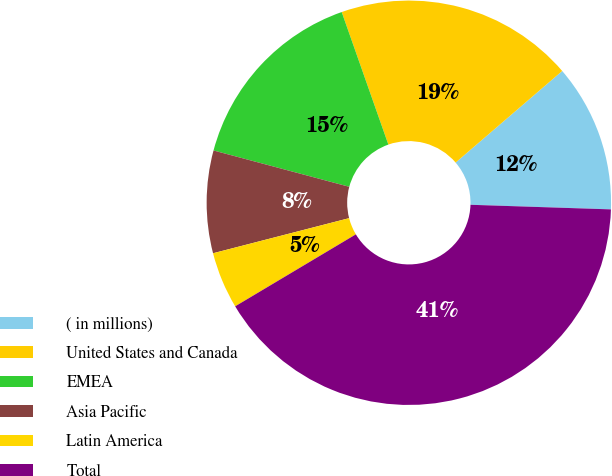<chart> <loc_0><loc_0><loc_500><loc_500><pie_chart><fcel>( in millions)<fcel>United States and Canada<fcel>EMEA<fcel>Asia Pacific<fcel>Latin America<fcel>Total<nl><fcel>11.82%<fcel>19.09%<fcel>15.45%<fcel>8.18%<fcel>4.54%<fcel>40.92%<nl></chart> 